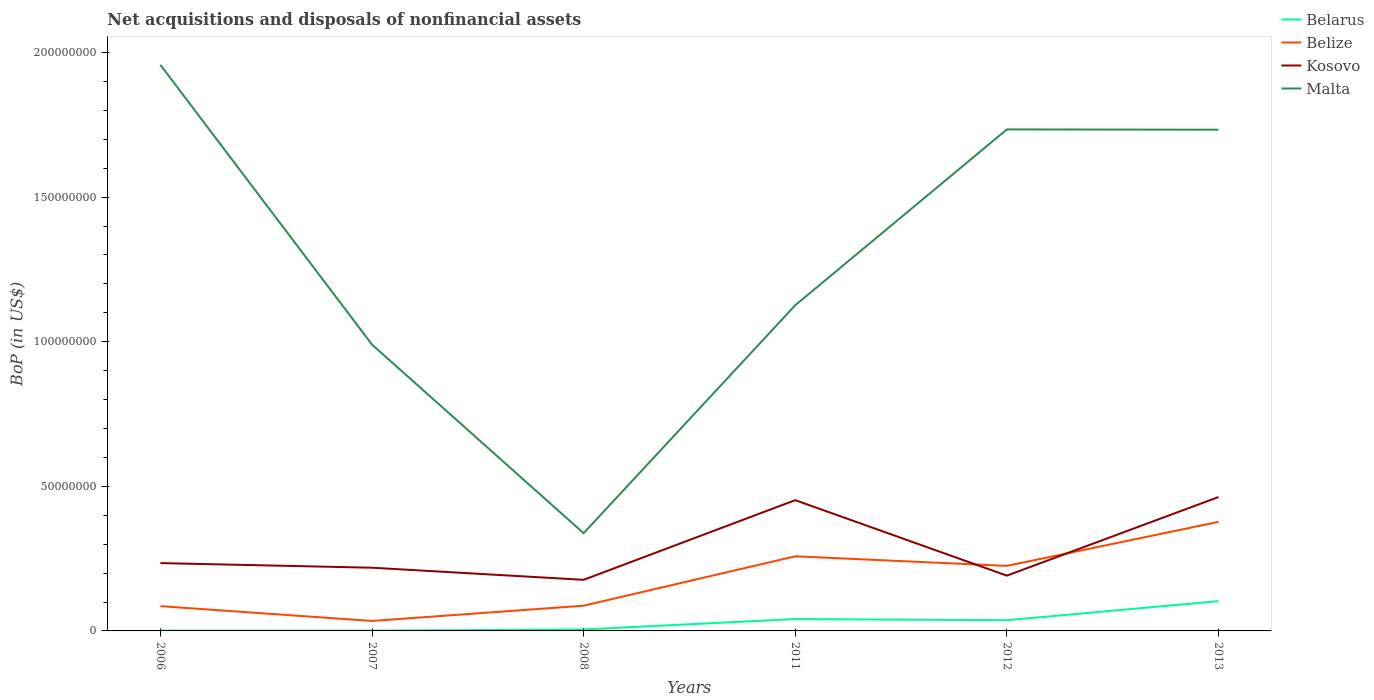Is the number of lines equal to the number of legend labels?
Provide a short and direct response. Yes. Across all years, what is the maximum Balance of Payments in Kosovo?
Your answer should be compact. 1.77e+07. In which year was the Balance of Payments in Belize maximum?
Offer a terse response. 2007. What is the total Balance of Payments in Belarus in the graph?
Provide a succinct answer. -4.00e+06. What is the difference between the highest and the second highest Balance of Payments in Belarus?
Offer a terse response. 1.02e+07. What is the difference between the highest and the lowest Balance of Payments in Belize?
Make the answer very short. 3. How many lines are there?
Your response must be concise. 4. How many years are there in the graph?
Provide a succinct answer. 6. Does the graph contain any zero values?
Offer a terse response. No. How many legend labels are there?
Your response must be concise. 4. What is the title of the graph?
Make the answer very short. Net acquisitions and disposals of nonfinancial assets. What is the label or title of the X-axis?
Give a very brief answer. Years. What is the label or title of the Y-axis?
Your answer should be compact. BoP (in US$). What is the BoP (in US$) of Belarus in 2006?
Provide a short and direct response. 1.00e+05. What is the BoP (in US$) in Belize in 2006?
Make the answer very short. 8.57e+06. What is the BoP (in US$) of Kosovo in 2006?
Your answer should be very brief. 2.35e+07. What is the BoP (in US$) in Malta in 2006?
Make the answer very short. 1.96e+08. What is the BoP (in US$) of Belize in 2007?
Make the answer very short. 3.45e+06. What is the BoP (in US$) of Kosovo in 2007?
Ensure brevity in your answer.  2.19e+07. What is the BoP (in US$) of Malta in 2007?
Keep it short and to the point. 9.90e+07. What is the BoP (in US$) of Belarus in 2008?
Provide a short and direct response. 5.00e+05. What is the BoP (in US$) of Belize in 2008?
Offer a very short reply. 8.73e+06. What is the BoP (in US$) in Kosovo in 2008?
Offer a very short reply. 1.77e+07. What is the BoP (in US$) of Malta in 2008?
Ensure brevity in your answer.  3.38e+07. What is the BoP (in US$) in Belarus in 2011?
Offer a very short reply. 4.10e+06. What is the BoP (in US$) in Belize in 2011?
Make the answer very short. 2.58e+07. What is the BoP (in US$) in Kosovo in 2011?
Give a very brief answer. 4.52e+07. What is the BoP (in US$) of Malta in 2011?
Make the answer very short. 1.13e+08. What is the BoP (in US$) in Belarus in 2012?
Offer a very short reply. 3.70e+06. What is the BoP (in US$) of Belize in 2012?
Ensure brevity in your answer.  2.25e+07. What is the BoP (in US$) of Kosovo in 2012?
Provide a succinct answer. 1.91e+07. What is the BoP (in US$) of Malta in 2012?
Your response must be concise. 1.73e+08. What is the BoP (in US$) in Belarus in 2013?
Ensure brevity in your answer.  1.03e+07. What is the BoP (in US$) of Belize in 2013?
Provide a succinct answer. 3.77e+07. What is the BoP (in US$) in Kosovo in 2013?
Your answer should be compact. 4.63e+07. What is the BoP (in US$) in Malta in 2013?
Offer a terse response. 1.73e+08. Across all years, what is the maximum BoP (in US$) in Belarus?
Your answer should be very brief. 1.03e+07. Across all years, what is the maximum BoP (in US$) of Belize?
Make the answer very short. 3.77e+07. Across all years, what is the maximum BoP (in US$) in Kosovo?
Your response must be concise. 4.63e+07. Across all years, what is the maximum BoP (in US$) in Malta?
Keep it short and to the point. 1.96e+08. Across all years, what is the minimum BoP (in US$) in Belize?
Ensure brevity in your answer.  3.45e+06. Across all years, what is the minimum BoP (in US$) in Kosovo?
Your response must be concise. 1.77e+07. Across all years, what is the minimum BoP (in US$) in Malta?
Your answer should be compact. 3.38e+07. What is the total BoP (in US$) of Belarus in the graph?
Provide a short and direct response. 1.88e+07. What is the total BoP (in US$) in Belize in the graph?
Offer a terse response. 1.07e+08. What is the total BoP (in US$) in Kosovo in the graph?
Offer a terse response. 1.74e+08. What is the total BoP (in US$) in Malta in the graph?
Your response must be concise. 7.88e+08. What is the difference between the BoP (in US$) in Belize in 2006 and that in 2007?
Your answer should be compact. 5.12e+06. What is the difference between the BoP (in US$) of Kosovo in 2006 and that in 2007?
Ensure brevity in your answer.  1.60e+06. What is the difference between the BoP (in US$) of Malta in 2006 and that in 2007?
Offer a very short reply. 9.67e+07. What is the difference between the BoP (in US$) in Belarus in 2006 and that in 2008?
Provide a short and direct response. -4.00e+05. What is the difference between the BoP (in US$) in Belize in 2006 and that in 2008?
Provide a succinct answer. -1.61e+05. What is the difference between the BoP (in US$) in Kosovo in 2006 and that in 2008?
Offer a terse response. 5.78e+06. What is the difference between the BoP (in US$) in Malta in 2006 and that in 2008?
Give a very brief answer. 1.62e+08. What is the difference between the BoP (in US$) of Belize in 2006 and that in 2011?
Keep it short and to the point. -1.72e+07. What is the difference between the BoP (in US$) of Kosovo in 2006 and that in 2011?
Make the answer very short. -2.18e+07. What is the difference between the BoP (in US$) in Malta in 2006 and that in 2011?
Your response must be concise. 8.31e+07. What is the difference between the BoP (in US$) in Belarus in 2006 and that in 2012?
Offer a very short reply. -3.60e+06. What is the difference between the BoP (in US$) in Belize in 2006 and that in 2012?
Keep it short and to the point. -1.39e+07. What is the difference between the BoP (in US$) of Kosovo in 2006 and that in 2012?
Make the answer very short. 4.34e+06. What is the difference between the BoP (in US$) in Malta in 2006 and that in 2012?
Provide a short and direct response. 2.23e+07. What is the difference between the BoP (in US$) of Belarus in 2006 and that in 2013?
Provide a succinct answer. -1.02e+07. What is the difference between the BoP (in US$) in Belize in 2006 and that in 2013?
Provide a short and direct response. -2.91e+07. What is the difference between the BoP (in US$) in Kosovo in 2006 and that in 2013?
Give a very brief answer. -2.28e+07. What is the difference between the BoP (in US$) of Malta in 2006 and that in 2013?
Provide a succinct answer. 2.24e+07. What is the difference between the BoP (in US$) in Belarus in 2007 and that in 2008?
Your answer should be very brief. -4.00e+05. What is the difference between the BoP (in US$) of Belize in 2007 and that in 2008?
Offer a terse response. -5.28e+06. What is the difference between the BoP (in US$) in Kosovo in 2007 and that in 2008?
Ensure brevity in your answer.  4.18e+06. What is the difference between the BoP (in US$) in Malta in 2007 and that in 2008?
Your answer should be compact. 6.52e+07. What is the difference between the BoP (in US$) of Belize in 2007 and that in 2011?
Your answer should be compact. -2.24e+07. What is the difference between the BoP (in US$) of Kosovo in 2007 and that in 2011?
Your answer should be very brief. -2.34e+07. What is the difference between the BoP (in US$) of Malta in 2007 and that in 2011?
Make the answer very short. -1.36e+07. What is the difference between the BoP (in US$) of Belarus in 2007 and that in 2012?
Offer a very short reply. -3.60e+06. What is the difference between the BoP (in US$) in Belize in 2007 and that in 2012?
Give a very brief answer. -1.90e+07. What is the difference between the BoP (in US$) of Kosovo in 2007 and that in 2012?
Your response must be concise. 2.74e+06. What is the difference between the BoP (in US$) of Malta in 2007 and that in 2012?
Your response must be concise. -7.44e+07. What is the difference between the BoP (in US$) in Belarus in 2007 and that in 2013?
Provide a short and direct response. -1.02e+07. What is the difference between the BoP (in US$) in Belize in 2007 and that in 2013?
Provide a succinct answer. -3.43e+07. What is the difference between the BoP (in US$) in Kosovo in 2007 and that in 2013?
Provide a succinct answer. -2.44e+07. What is the difference between the BoP (in US$) of Malta in 2007 and that in 2013?
Your answer should be very brief. -7.43e+07. What is the difference between the BoP (in US$) of Belarus in 2008 and that in 2011?
Your response must be concise. -3.60e+06. What is the difference between the BoP (in US$) in Belize in 2008 and that in 2011?
Make the answer very short. -1.71e+07. What is the difference between the BoP (in US$) in Kosovo in 2008 and that in 2011?
Your response must be concise. -2.75e+07. What is the difference between the BoP (in US$) of Malta in 2008 and that in 2011?
Make the answer very short. -7.88e+07. What is the difference between the BoP (in US$) in Belarus in 2008 and that in 2012?
Your answer should be very brief. -3.20e+06. What is the difference between the BoP (in US$) of Belize in 2008 and that in 2012?
Provide a short and direct response. -1.38e+07. What is the difference between the BoP (in US$) of Kosovo in 2008 and that in 2012?
Make the answer very short. -1.44e+06. What is the difference between the BoP (in US$) in Malta in 2008 and that in 2012?
Your answer should be very brief. -1.40e+08. What is the difference between the BoP (in US$) in Belarus in 2008 and that in 2013?
Make the answer very short. -9.80e+06. What is the difference between the BoP (in US$) of Belize in 2008 and that in 2013?
Keep it short and to the point. -2.90e+07. What is the difference between the BoP (in US$) of Kosovo in 2008 and that in 2013?
Provide a short and direct response. -2.86e+07. What is the difference between the BoP (in US$) of Malta in 2008 and that in 2013?
Make the answer very short. -1.40e+08. What is the difference between the BoP (in US$) of Belize in 2011 and that in 2012?
Provide a succinct answer. 3.31e+06. What is the difference between the BoP (in US$) in Kosovo in 2011 and that in 2012?
Keep it short and to the point. 2.61e+07. What is the difference between the BoP (in US$) in Malta in 2011 and that in 2012?
Offer a terse response. -6.08e+07. What is the difference between the BoP (in US$) in Belarus in 2011 and that in 2013?
Offer a terse response. -6.20e+06. What is the difference between the BoP (in US$) in Belize in 2011 and that in 2013?
Keep it short and to the point. -1.19e+07. What is the difference between the BoP (in US$) of Kosovo in 2011 and that in 2013?
Give a very brief answer. -1.08e+06. What is the difference between the BoP (in US$) of Malta in 2011 and that in 2013?
Offer a terse response. -6.07e+07. What is the difference between the BoP (in US$) of Belarus in 2012 and that in 2013?
Your answer should be compact. -6.60e+06. What is the difference between the BoP (in US$) of Belize in 2012 and that in 2013?
Your answer should be very brief. -1.52e+07. What is the difference between the BoP (in US$) in Kosovo in 2012 and that in 2013?
Provide a short and direct response. -2.72e+07. What is the difference between the BoP (in US$) of Malta in 2012 and that in 2013?
Your answer should be compact. 1.08e+05. What is the difference between the BoP (in US$) in Belarus in 2006 and the BoP (in US$) in Belize in 2007?
Your answer should be compact. -3.35e+06. What is the difference between the BoP (in US$) of Belarus in 2006 and the BoP (in US$) of Kosovo in 2007?
Keep it short and to the point. -2.18e+07. What is the difference between the BoP (in US$) of Belarus in 2006 and the BoP (in US$) of Malta in 2007?
Make the answer very short. -9.89e+07. What is the difference between the BoP (in US$) in Belize in 2006 and the BoP (in US$) in Kosovo in 2007?
Ensure brevity in your answer.  -1.33e+07. What is the difference between the BoP (in US$) in Belize in 2006 and the BoP (in US$) in Malta in 2007?
Your answer should be very brief. -9.04e+07. What is the difference between the BoP (in US$) of Kosovo in 2006 and the BoP (in US$) of Malta in 2007?
Your answer should be very brief. -7.56e+07. What is the difference between the BoP (in US$) in Belarus in 2006 and the BoP (in US$) in Belize in 2008?
Provide a succinct answer. -8.63e+06. What is the difference between the BoP (in US$) of Belarus in 2006 and the BoP (in US$) of Kosovo in 2008?
Your answer should be compact. -1.76e+07. What is the difference between the BoP (in US$) in Belarus in 2006 and the BoP (in US$) in Malta in 2008?
Your response must be concise. -3.37e+07. What is the difference between the BoP (in US$) of Belize in 2006 and the BoP (in US$) of Kosovo in 2008?
Offer a terse response. -9.11e+06. What is the difference between the BoP (in US$) of Belize in 2006 and the BoP (in US$) of Malta in 2008?
Ensure brevity in your answer.  -2.52e+07. What is the difference between the BoP (in US$) of Kosovo in 2006 and the BoP (in US$) of Malta in 2008?
Give a very brief answer. -1.03e+07. What is the difference between the BoP (in US$) of Belarus in 2006 and the BoP (in US$) of Belize in 2011?
Keep it short and to the point. -2.57e+07. What is the difference between the BoP (in US$) of Belarus in 2006 and the BoP (in US$) of Kosovo in 2011?
Ensure brevity in your answer.  -4.51e+07. What is the difference between the BoP (in US$) in Belarus in 2006 and the BoP (in US$) in Malta in 2011?
Offer a very short reply. -1.13e+08. What is the difference between the BoP (in US$) in Belize in 2006 and the BoP (in US$) in Kosovo in 2011?
Make the answer very short. -3.67e+07. What is the difference between the BoP (in US$) in Belize in 2006 and the BoP (in US$) in Malta in 2011?
Ensure brevity in your answer.  -1.04e+08. What is the difference between the BoP (in US$) of Kosovo in 2006 and the BoP (in US$) of Malta in 2011?
Ensure brevity in your answer.  -8.92e+07. What is the difference between the BoP (in US$) in Belarus in 2006 and the BoP (in US$) in Belize in 2012?
Provide a short and direct response. -2.24e+07. What is the difference between the BoP (in US$) in Belarus in 2006 and the BoP (in US$) in Kosovo in 2012?
Offer a very short reply. -1.90e+07. What is the difference between the BoP (in US$) in Belarus in 2006 and the BoP (in US$) in Malta in 2012?
Provide a short and direct response. -1.73e+08. What is the difference between the BoP (in US$) of Belize in 2006 and the BoP (in US$) of Kosovo in 2012?
Ensure brevity in your answer.  -1.06e+07. What is the difference between the BoP (in US$) in Belize in 2006 and the BoP (in US$) in Malta in 2012?
Offer a very short reply. -1.65e+08. What is the difference between the BoP (in US$) of Kosovo in 2006 and the BoP (in US$) of Malta in 2012?
Your answer should be very brief. -1.50e+08. What is the difference between the BoP (in US$) of Belarus in 2006 and the BoP (in US$) of Belize in 2013?
Keep it short and to the point. -3.76e+07. What is the difference between the BoP (in US$) of Belarus in 2006 and the BoP (in US$) of Kosovo in 2013?
Provide a short and direct response. -4.62e+07. What is the difference between the BoP (in US$) in Belarus in 2006 and the BoP (in US$) in Malta in 2013?
Give a very brief answer. -1.73e+08. What is the difference between the BoP (in US$) in Belize in 2006 and the BoP (in US$) in Kosovo in 2013?
Offer a very short reply. -3.77e+07. What is the difference between the BoP (in US$) of Belize in 2006 and the BoP (in US$) of Malta in 2013?
Make the answer very short. -1.65e+08. What is the difference between the BoP (in US$) in Kosovo in 2006 and the BoP (in US$) in Malta in 2013?
Ensure brevity in your answer.  -1.50e+08. What is the difference between the BoP (in US$) of Belarus in 2007 and the BoP (in US$) of Belize in 2008?
Your answer should be compact. -8.63e+06. What is the difference between the BoP (in US$) of Belarus in 2007 and the BoP (in US$) of Kosovo in 2008?
Ensure brevity in your answer.  -1.76e+07. What is the difference between the BoP (in US$) of Belarus in 2007 and the BoP (in US$) of Malta in 2008?
Offer a very short reply. -3.37e+07. What is the difference between the BoP (in US$) in Belize in 2007 and the BoP (in US$) in Kosovo in 2008?
Offer a terse response. -1.42e+07. What is the difference between the BoP (in US$) of Belize in 2007 and the BoP (in US$) of Malta in 2008?
Offer a very short reply. -3.03e+07. What is the difference between the BoP (in US$) in Kosovo in 2007 and the BoP (in US$) in Malta in 2008?
Your answer should be very brief. -1.19e+07. What is the difference between the BoP (in US$) of Belarus in 2007 and the BoP (in US$) of Belize in 2011?
Offer a very short reply. -2.57e+07. What is the difference between the BoP (in US$) in Belarus in 2007 and the BoP (in US$) in Kosovo in 2011?
Provide a succinct answer. -4.51e+07. What is the difference between the BoP (in US$) in Belarus in 2007 and the BoP (in US$) in Malta in 2011?
Ensure brevity in your answer.  -1.13e+08. What is the difference between the BoP (in US$) of Belize in 2007 and the BoP (in US$) of Kosovo in 2011?
Offer a very short reply. -4.18e+07. What is the difference between the BoP (in US$) in Belize in 2007 and the BoP (in US$) in Malta in 2011?
Offer a very short reply. -1.09e+08. What is the difference between the BoP (in US$) in Kosovo in 2007 and the BoP (in US$) in Malta in 2011?
Your answer should be very brief. -9.08e+07. What is the difference between the BoP (in US$) in Belarus in 2007 and the BoP (in US$) in Belize in 2012?
Make the answer very short. -2.24e+07. What is the difference between the BoP (in US$) of Belarus in 2007 and the BoP (in US$) of Kosovo in 2012?
Your answer should be very brief. -1.90e+07. What is the difference between the BoP (in US$) of Belarus in 2007 and the BoP (in US$) of Malta in 2012?
Your response must be concise. -1.73e+08. What is the difference between the BoP (in US$) of Belize in 2007 and the BoP (in US$) of Kosovo in 2012?
Your response must be concise. -1.57e+07. What is the difference between the BoP (in US$) in Belize in 2007 and the BoP (in US$) in Malta in 2012?
Give a very brief answer. -1.70e+08. What is the difference between the BoP (in US$) in Kosovo in 2007 and the BoP (in US$) in Malta in 2012?
Make the answer very short. -1.52e+08. What is the difference between the BoP (in US$) of Belarus in 2007 and the BoP (in US$) of Belize in 2013?
Your answer should be compact. -3.76e+07. What is the difference between the BoP (in US$) of Belarus in 2007 and the BoP (in US$) of Kosovo in 2013?
Offer a very short reply. -4.62e+07. What is the difference between the BoP (in US$) in Belarus in 2007 and the BoP (in US$) in Malta in 2013?
Your answer should be very brief. -1.73e+08. What is the difference between the BoP (in US$) of Belize in 2007 and the BoP (in US$) of Kosovo in 2013?
Offer a very short reply. -4.28e+07. What is the difference between the BoP (in US$) in Belize in 2007 and the BoP (in US$) in Malta in 2013?
Keep it short and to the point. -1.70e+08. What is the difference between the BoP (in US$) in Kosovo in 2007 and the BoP (in US$) in Malta in 2013?
Provide a short and direct response. -1.51e+08. What is the difference between the BoP (in US$) in Belarus in 2008 and the BoP (in US$) in Belize in 2011?
Ensure brevity in your answer.  -2.53e+07. What is the difference between the BoP (in US$) of Belarus in 2008 and the BoP (in US$) of Kosovo in 2011?
Keep it short and to the point. -4.47e+07. What is the difference between the BoP (in US$) in Belarus in 2008 and the BoP (in US$) in Malta in 2011?
Your answer should be very brief. -1.12e+08. What is the difference between the BoP (in US$) of Belize in 2008 and the BoP (in US$) of Kosovo in 2011?
Offer a very short reply. -3.65e+07. What is the difference between the BoP (in US$) of Belize in 2008 and the BoP (in US$) of Malta in 2011?
Make the answer very short. -1.04e+08. What is the difference between the BoP (in US$) of Kosovo in 2008 and the BoP (in US$) of Malta in 2011?
Ensure brevity in your answer.  -9.49e+07. What is the difference between the BoP (in US$) of Belarus in 2008 and the BoP (in US$) of Belize in 2012?
Give a very brief answer. -2.20e+07. What is the difference between the BoP (in US$) of Belarus in 2008 and the BoP (in US$) of Kosovo in 2012?
Keep it short and to the point. -1.86e+07. What is the difference between the BoP (in US$) in Belarus in 2008 and the BoP (in US$) in Malta in 2012?
Keep it short and to the point. -1.73e+08. What is the difference between the BoP (in US$) in Belize in 2008 and the BoP (in US$) in Kosovo in 2012?
Provide a succinct answer. -1.04e+07. What is the difference between the BoP (in US$) in Belize in 2008 and the BoP (in US$) in Malta in 2012?
Offer a very short reply. -1.65e+08. What is the difference between the BoP (in US$) of Kosovo in 2008 and the BoP (in US$) of Malta in 2012?
Offer a terse response. -1.56e+08. What is the difference between the BoP (in US$) in Belarus in 2008 and the BoP (in US$) in Belize in 2013?
Offer a terse response. -3.72e+07. What is the difference between the BoP (in US$) of Belarus in 2008 and the BoP (in US$) of Kosovo in 2013?
Give a very brief answer. -4.58e+07. What is the difference between the BoP (in US$) of Belarus in 2008 and the BoP (in US$) of Malta in 2013?
Make the answer very short. -1.73e+08. What is the difference between the BoP (in US$) of Belize in 2008 and the BoP (in US$) of Kosovo in 2013?
Give a very brief answer. -3.76e+07. What is the difference between the BoP (in US$) of Belize in 2008 and the BoP (in US$) of Malta in 2013?
Offer a terse response. -1.65e+08. What is the difference between the BoP (in US$) of Kosovo in 2008 and the BoP (in US$) of Malta in 2013?
Your answer should be very brief. -1.56e+08. What is the difference between the BoP (in US$) of Belarus in 2011 and the BoP (in US$) of Belize in 2012?
Provide a short and direct response. -1.84e+07. What is the difference between the BoP (in US$) in Belarus in 2011 and the BoP (in US$) in Kosovo in 2012?
Provide a succinct answer. -1.50e+07. What is the difference between the BoP (in US$) of Belarus in 2011 and the BoP (in US$) of Malta in 2012?
Your answer should be compact. -1.69e+08. What is the difference between the BoP (in US$) in Belize in 2011 and the BoP (in US$) in Kosovo in 2012?
Provide a short and direct response. 6.69e+06. What is the difference between the BoP (in US$) in Belize in 2011 and the BoP (in US$) in Malta in 2012?
Your answer should be very brief. -1.48e+08. What is the difference between the BoP (in US$) in Kosovo in 2011 and the BoP (in US$) in Malta in 2012?
Provide a short and direct response. -1.28e+08. What is the difference between the BoP (in US$) of Belarus in 2011 and the BoP (in US$) of Belize in 2013?
Ensure brevity in your answer.  -3.36e+07. What is the difference between the BoP (in US$) of Belarus in 2011 and the BoP (in US$) of Kosovo in 2013?
Your answer should be very brief. -4.22e+07. What is the difference between the BoP (in US$) in Belarus in 2011 and the BoP (in US$) in Malta in 2013?
Your answer should be very brief. -1.69e+08. What is the difference between the BoP (in US$) of Belize in 2011 and the BoP (in US$) of Kosovo in 2013?
Your answer should be very brief. -2.05e+07. What is the difference between the BoP (in US$) of Belize in 2011 and the BoP (in US$) of Malta in 2013?
Offer a terse response. -1.48e+08. What is the difference between the BoP (in US$) of Kosovo in 2011 and the BoP (in US$) of Malta in 2013?
Offer a terse response. -1.28e+08. What is the difference between the BoP (in US$) of Belarus in 2012 and the BoP (in US$) of Belize in 2013?
Ensure brevity in your answer.  -3.40e+07. What is the difference between the BoP (in US$) in Belarus in 2012 and the BoP (in US$) in Kosovo in 2013?
Your answer should be compact. -4.26e+07. What is the difference between the BoP (in US$) in Belarus in 2012 and the BoP (in US$) in Malta in 2013?
Provide a succinct answer. -1.70e+08. What is the difference between the BoP (in US$) in Belize in 2012 and the BoP (in US$) in Kosovo in 2013?
Your answer should be very brief. -2.38e+07. What is the difference between the BoP (in US$) of Belize in 2012 and the BoP (in US$) of Malta in 2013?
Your answer should be very brief. -1.51e+08. What is the difference between the BoP (in US$) in Kosovo in 2012 and the BoP (in US$) in Malta in 2013?
Offer a terse response. -1.54e+08. What is the average BoP (in US$) in Belarus per year?
Make the answer very short. 3.13e+06. What is the average BoP (in US$) of Belize per year?
Offer a very short reply. 1.78e+07. What is the average BoP (in US$) in Kosovo per year?
Ensure brevity in your answer.  2.89e+07. What is the average BoP (in US$) in Malta per year?
Provide a succinct answer. 1.31e+08. In the year 2006, what is the difference between the BoP (in US$) in Belarus and BoP (in US$) in Belize?
Keep it short and to the point. -8.47e+06. In the year 2006, what is the difference between the BoP (in US$) of Belarus and BoP (in US$) of Kosovo?
Make the answer very short. -2.34e+07. In the year 2006, what is the difference between the BoP (in US$) of Belarus and BoP (in US$) of Malta?
Provide a succinct answer. -1.96e+08. In the year 2006, what is the difference between the BoP (in US$) of Belize and BoP (in US$) of Kosovo?
Offer a terse response. -1.49e+07. In the year 2006, what is the difference between the BoP (in US$) in Belize and BoP (in US$) in Malta?
Offer a very short reply. -1.87e+08. In the year 2006, what is the difference between the BoP (in US$) of Kosovo and BoP (in US$) of Malta?
Make the answer very short. -1.72e+08. In the year 2007, what is the difference between the BoP (in US$) of Belarus and BoP (in US$) of Belize?
Your response must be concise. -3.35e+06. In the year 2007, what is the difference between the BoP (in US$) of Belarus and BoP (in US$) of Kosovo?
Offer a very short reply. -2.18e+07. In the year 2007, what is the difference between the BoP (in US$) in Belarus and BoP (in US$) in Malta?
Make the answer very short. -9.89e+07. In the year 2007, what is the difference between the BoP (in US$) in Belize and BoP (in US$) in Kosovo?
Your response must be concise. -1.84e+07. In the year 2007, what is the difference between the BoP (in US$) in Belize and BoP (in US$) in Malta?
Make the answer very short. -9.56e+07. In the year 2007, what is the difference between the BoP (in US$) of Kosovo and BoP (in US$) of Malta?
Your answer should be very brief. -7.72e+07. In the year 2008, what is the difference between the BoP (in US$) in Belarus and BoP (in US$) in Belize?
Ensure brevity in your answer.  -8.23e+06. In the year 2008, what is the difference between the BoP (in US$) in Belarus and BoP (in US$) in Kosovo?
Your response must be concise. -1.72e+07. In the year 2008, what is the difference between the BoP (in US$) of Belarus and BoP (in US$) of Malta?
Provide a short and direct response. -3.33e+07. In the year 2008, what is the difference between the BoP (in US$) of Belize and BoP (in US$) of Kosovo?
Offer a very short reply. -8.95e+06. In the year 2008, what is the difference between the BoP (in US$) in Belize and BoP (in US$) in Malta?
Make the answer very short. -2.51e+07. In the year 2008, what is the difference between the BoP (in US$) in Kosovo and BoP (in US$) in Malta?
Make the answer very short. -1.61e+07. In the year 2011, what is the difference between the BoP (in US$) of Belarus and BoP (in US$) of Belize?
Offer a very short reply. -2.17e+07. In the year 2011, what is the difference between the BoP (in US$) of Belarus and BoP (in US$) of Kosovo?
Give a very brief answer. -4.11e+07. In the year 2011, what is the difference between the BoP (in US$) of Belarus and BoP (in US$) of Malta?
Your answer should be very brief. -1.09e+08. In the year 2011, what is the difference between the BoP (in US$) in Belize and BoP (in US$) in Kosovo?
Offer a very short reply. -1.94e+07. In the year 2011, what is the difference between the BoP (in US$) of Belize and BoP (in US$) of Malta?
Offer a terse response. -8.68e+07. In the year 2011, what is the difference between the BoP (in US$) of Kosovo and BoP (in US$) of Malta?
Give a very brief answer. -6.74e+07. In the year 2012, what is the difference between the BoP (in US$) of Belarus and BoP (in US$) of Belize?
Make the answer very short. -1.88e+07. In the year 2012, what is the difference between the BoP (in US$) in Belarus and BoP (in US$) in Kosovo?
Provide a short and direct response. -1.54e+07. In the year 2012, what is the difference between the BoP (in US$) in Belarus and BoP (in US$) in Malta?
Your response must be concise. -1.70e+08. In the year 2012, what is the difference between the BoP (in US$) of Belize and BoP (in US$) of Kosovo?
Provide a succinct answer. 3.37e+06. In the year 2012, what is the difference between the BoP (in US$) of Belize and BoP (in US$) of Malta?
Give a very brief answer. -1.51e+08. In the year 2012, what is the difference between the BoP (in US$) in Kosovo and BoP (in US$) in Malta?
Give a very brief answer. -1.54e+08. In the year 2013, what is the difference between the BoP (in US$) in Belarus and BoP (in US$) in Belize?
Keep it short and to the point. -2.74e+07. In the year 2013, what is the difference between the BoP (in US$) in Belarus and BoP (in US$) in Kosovo?
Your answer should be compact. -3.60e+07. In the year 2013, what is the difference between the BoP (in US$) in Belarus and BoP (in US$) in Malta?
Make the answer very short. -1.63e+08. In the year 2013, what is the difference between the BoP (in US$) of Belize and BoP (in US$) of Kosovo?
Provide a succinct answer. -8.59e+06. In the year 2013, what is the difference between the BoP (in US$) of Belize and BoP (in US$) of Malta?
Keep it short and to the point. -1.36e+08. In the year 2013, what is the difference between the BoP (in US$) of Kosovo and BoP (in US$) of Malta?
Give a very brief answer. -1.27e+08. What is the ratio of the BoP (in US$) of Belize in 2006 to that in 2007?
Provide a short and direct response. 2.49. What is the ratio of the BoP (in US$) in Kosovo in 2006 to that in 2007?
Keep it short and to the point. 1.07. What is the ratio of the BoP (in US$) of Malta in 2006 to that in 2007?
Provide a short and direct response. 1.98. What is the ratio of the BoP (in US$) of Belarus in 2006 to that in 2008?
Make the answer very short. 0.2. What is the ratio of the BoP (in US$) in Belize in 2006 to that in 2008?
Your answer should be very brief. 0.98. What is the ratio of the BoP (in US$) of Kosovo in 2006 to that in 2008?
Keep it short and to the point. 1.33. What is the ratio of the BoP (in US$) of Malta in 2006 to that in 2008?
Your answer should be compact. 5.79. What is the ratio of the BoP (in US$) in Belarus in 2006 to that in 2011?
Give a very brief answer. 0.02. What is the ratio of the BoP (in US$) of Belize in 2006 to that in 2011?
Your answer should be compact. 0.33. What is the ratio of the BoP (in US$) of Kosovo in 2006 to that in 2011?
Keep it short and to the point. 0.52. What is the ratio of the BoP (in US$) of Malta in 2006 to that in 2011?
Make the answer very short. 1.74. What is the ratio of the BoP (in US$) of Belarus in 2006 to that in 2012?
Provide a succinct answer. 0.03. What is the ratio of the BoP (in US$) of Belize in 2006 to that in 2012?
Offer a very short reply. 0.38. What is the ratio of the BoP (in US$) in Kosovo in 2006 to that in 2012?
Offer a very short reply. 1.23. What is the ratio of the BoP (in US$) in Malta in 2006 to that in 2012?
Offer a terse response. 1.13. What is the ratio of the BoP (in US$) in Belarus in 2006 to that in 2013?
Your answer should be compact. 0.01. What is the ratio of the BoP (in US$) of Belize in 2006 to that in 2013?
Provide a short and direct response. 0.23. What is the ratio of the BoP (in US$) in Kosovo in 2006 to that in 2013?
Give a very brief answer. 0.51. What is the ratio of the BoP (in US$) of Malta in 2006 to that in 2013?
Your answer should be compact. 1.13. What is the ratio of the BoP (in US$) in Belize in 2007 to that in 2008?
Provide a succinct answer. 0.39. What is the ratio of the BoP (in US$) in Kosovo in 2007 to that in 2008?
Your response must be concise. 1.24. What is the ratio of the BoP (in US$) of Malta in 2007 to that in 2008?
Provide a short and direct response. 2.93. What is the ratio of the BoP (in US$) of Belarus in 2007 to that in 2011?
Offer a terse response. 0.02. What is the ratio of the BoP (in US$) in Belize in 2007 to that in 2011?
Provide a short and direct response. 0.13. What is the ratio of the BoP (in US$) of Kosovo in 2007 to that in 2011?
Your response must be concise. 0.48. What is the ratio of the BoP (in US$) of Malta in 2007 to that in 2011?
Offer a terse response. 0.88. What is the ratio of the BoP (in US$) in Belarus in 2007 to that in 2012?
Your response must be concise. 0.03. What is the ratio of the BoP (in US$) of Belize in 2007 to that in 2012?
Your response must be concise. 0.15. What is the ratio of the BoP (in US$) in Kosovo in 2007 to that in 2012?
Provide a short and direct response. 1.14. What is the ratio of the BoP (in US$) of Malta in 2007 to that in 2012?
Offer a very short reply. 0.57. What is the ratio of the BoP (in US$) of Belarus in 2007 to that in 2013?
Give a very brief answer. 0.01. What is the ratio of the BoP (in US$) of Belize in 2007 to that in 2013?
Make the answer very short. 0.09. What is the ratio of the BoP (in US$) of Kosovo in 2007 to that in 2013?
Your response must be concise. 0.47. What is the ratio of the BoP (in US$) of Malta in 2007 to that in 2013?
Ensure brevity in your answer.  0.57. What is the ratio of the BoP (in US$) in Belarus in 2008 to that in 2011?
Offer a terse response. 0.12. What is the ratio of the BoP (in US$) of Belize in 2008 to that in 2011?
Offer a very short reply. 0.34. What is the ratio of the BoP (in US$) of Kosovo in 2008 to that in 2011?
Provide a short and direct response. 0.39. What is the ratio of the BoP (in US$) of Malta in 2008 to that in 2011?
Offer a very short reply. 0.3. What is the ratio of the BoP (in US$) of Belarus in 2008 to that in 2012?
Your response must be concise. 0.14. What is the ratio of the BoP (in US$) in Belize in 2008 to that in 2012?
Provide a short and direct response. 0.39. What is the ratio of the BoP (in US$) in Kosovo in 2008 to that in 2012?
Keep it short and to the point. 0.92. What is the ratio of the BoP (in US$) in Malta in 2008 to that in 2012?
Your answer should be compact. 0.19. What is the ratio of the BoP (in US$) of Belarus in 2008 to that in 2013?
Ensure brevity in your answer.  0.05. What is the ratio of the BoP (in US$) of Belize in 2008 to that in 2013?
Offer a very short reply. 0.23. What is the ratio of the BoP (in US$) in Kosovo in 2008 to that in 2013?
Make the answer very short. 0.38. What is the ratio of the BoP (in US$) in Malta in 2008 to that in 2013?
Give a very brief answer. 0.2. What is the ratio of the BoP (in US$) of Belarus in 2011 to that in 2012?
Offer a very short reply. 1.11. What is the ratio of the BoP (in US$) of Belize in 2011 to that in 2012?
Ensure brevity in your answer.  1.15. What is the ratio of the BoP (in US$) of Kosovo in 2011 to that in 2012?
Provide a short and direct response. 2.37. What is the ratio of the BoP (in US$) of Malta in 2011 to that in 2012?
Make the answer very short. 0.65. What is the ratio of the BoP (in US$) in Belarus in 2011 to that in 2013?
Keep it short and to the point. 0.4. What is the ratio of the BoP (in US$) in Belize in 2011 to that in 2013?
Provide a succinct answer. 0.68. What is the ratio of the BoP (in US$) of Kosovo in 2011 to that in 2013?
Keep it short and to the point. 0.98. What is the ratio of the BoP (in US$) of Malta in 2011 to that in 2013?
Your answer should be very brief. 0.65. What is the ratio of the BoP (in US$) of Belarus in 2012 to that in 2013?
Your response must be concise. 0.36. What is the ratio of the BoP (in US$) of Belize in 2012 to that in 2013?
Your answer should be very brief. 0.6. What is the ratio of the BoP (in US$) of Kosovo in 2012 to that in 2013?
Provide a succinct answer. 0.41. What is the ratio of the BoP (in US$) of Malta in 2012 to that in 2013?
Offer a very short reply. 1. What is the difference between the highest and the second highest BoP (in US$) of Belarus?
Offer a very short reply. 6.20e+06. What is the difference between the highest and the second highest BoP (in US$) in Belize?
Provide a succinct answer. 1.19e+07. What is the difference between the highest and the second highest BoP (in US$) in Kosovo?
Your answer should be very brief. 1.08e+06. What is the difference between the highest and the second highest BoP (in US$) in Malta?
Ensure brevity in your answer.  2.23e+07. What is the difference between the highest and the lowest BoP (in US$) in Belarus?
Keep it short and to the point. 1.02e+07. What is the difference between the highest and the lowest BoP (in US$) of Belize?
Your answer should be very brief. 3.43e+07. What is the difference between the highest and the lowest BoP (in US$) of Kosovo?
Ensure brevity in your answer.  2.86e+07. What is the difference between the highest and the lowest BoP (in US$) of Malta?
Make the answer very short. 1.62e+08. 